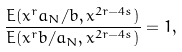<formula> <loc_0><loc_0><loc_500><loc_500>\frac { E ( x ^ { r } a _ { N } / b , x ^ { 2 r - 4 s } ) } { E ( x ^ { r } b / a _ { N } , x ^ { 2 r - 4 s } ) } = 1 ,</formula> 